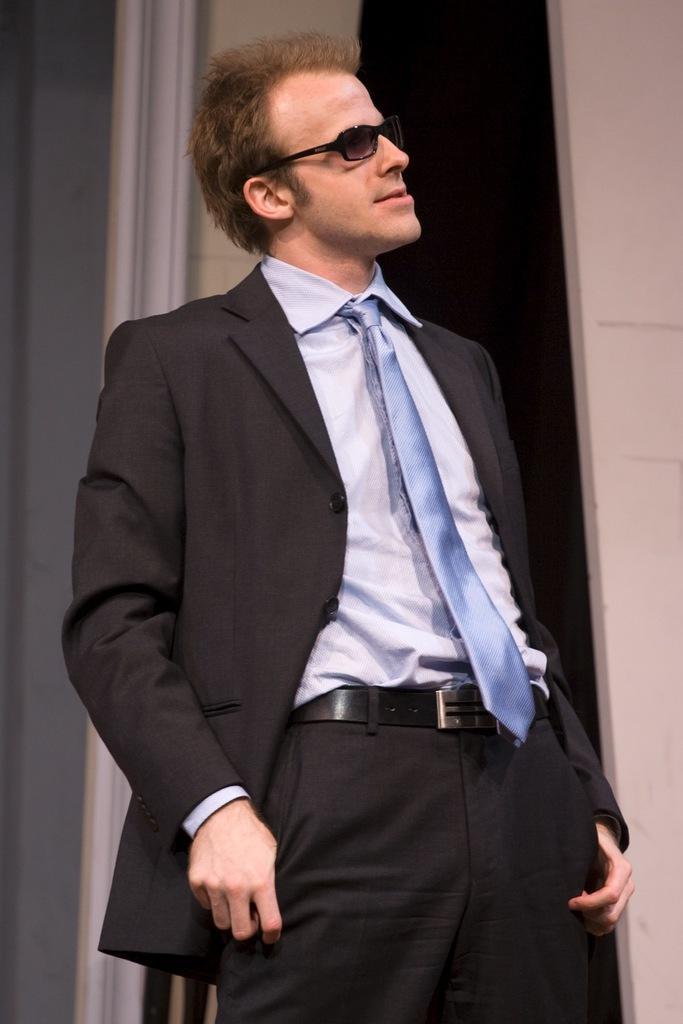Describe this image in one or two sentences. In this image there is a man standing. He is wearing a suit and spectacles. Behind him there is a wall. 